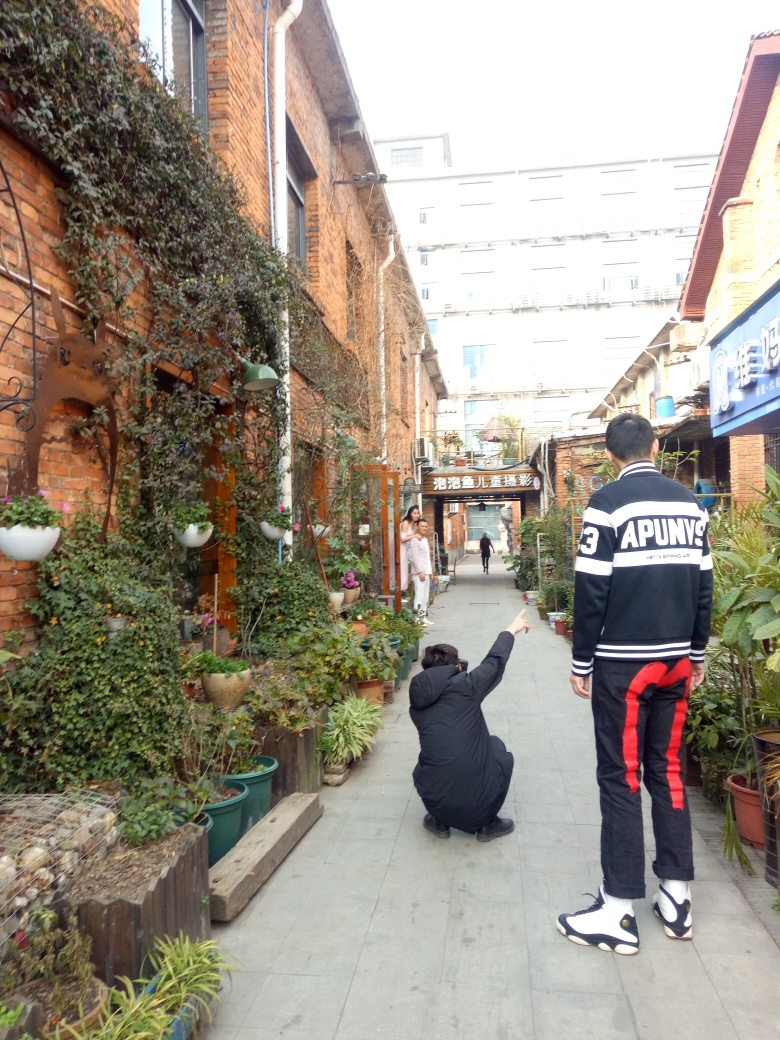Can you describe what's happening in this scene? In the image, it appears there is one person taking a photograph of another person, who is pointing at something in the distance. They are in a narrow alley lined with potted plants and brick walls, giving the area a cozy and rustic atmosphere. What time of day does it seem to be? It appears to be daytime with natural light, judging by the shadows and ambient light, likely in the morning or early afternoon. 